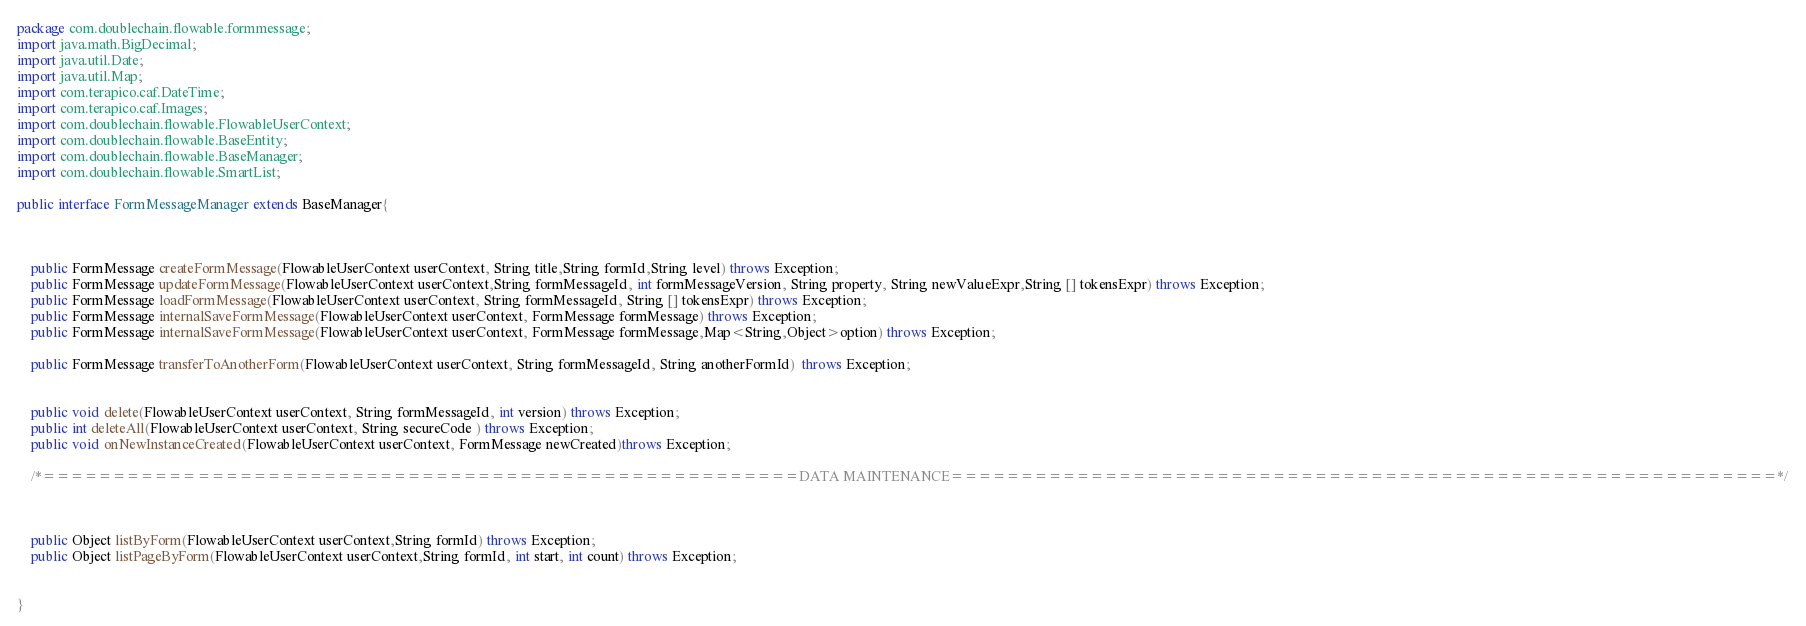Convert code to text. <code><loc_0><loc_0><loc_500><loc_500><_Java_>
package com.doublechain.flowable.formmessage;
import java.math.BigDecimal;
import java.util.Date;
import java.util.Map;
import com.terapico.caf.DateTime;
import com.terapico.caf.Images;
import com.doublechain.flowable.FlowableUserContext;
import com.doublechain.flowable.BaseEntity;
import com.doublechain.flowable.BaseManager;
import com.doublechain.flowable.SmartList;

public interface FormMessageManager extends BaseManager{

		

	public FormMessage createFormMessage(FlowableUserContext userContext, String title,String formId,String level) throws Exception;	
	public FormMessage updateFormMessage(FlowableUserContext userContext,String formMessageId, int formMessageVersion, String property, String newValueExpr,String [] tokensExpr) throws Exception;
	public FormMessage loadFormMessage(FlowableUserContext userContext, String formMessageId, String [] tokensExpr) throws Exception;
	public FormMessage internalSaveFormMessage(FlowableUserContext userContext, FormMessage formMessage) throws Exception;
	public FormMessage internalSaveFormMessage(FlowableUserContext userContext, FormMessage formMessage,Map<String,Object>option) throws Exception;
	
	public FormMessage transferToAnotherForm(FlowableUserContext userContext, String formMessageId, String anotherFormId)  throws Exception;
 

	public void delete(FlowableUserContext userContext, String formMessageId, int version) throws Exception;
	public int deleteAll(FlowableUserContext userContext, String secureCode ) throws Exception;
	public void onNewInstanceCreated(FlowableUserContext userContext, FormMessage newCreated)throws Exception;

	/*======================================================DATA MAINTENANCE===========================================================*/
	


	public Object listByForm(FlowableUserContext userContext,String formId) throws Exception;
	public Object listPageByForm(FlowableUserContext userContext,String formId, int start, int count) throws Exception;
  

}


</code> 